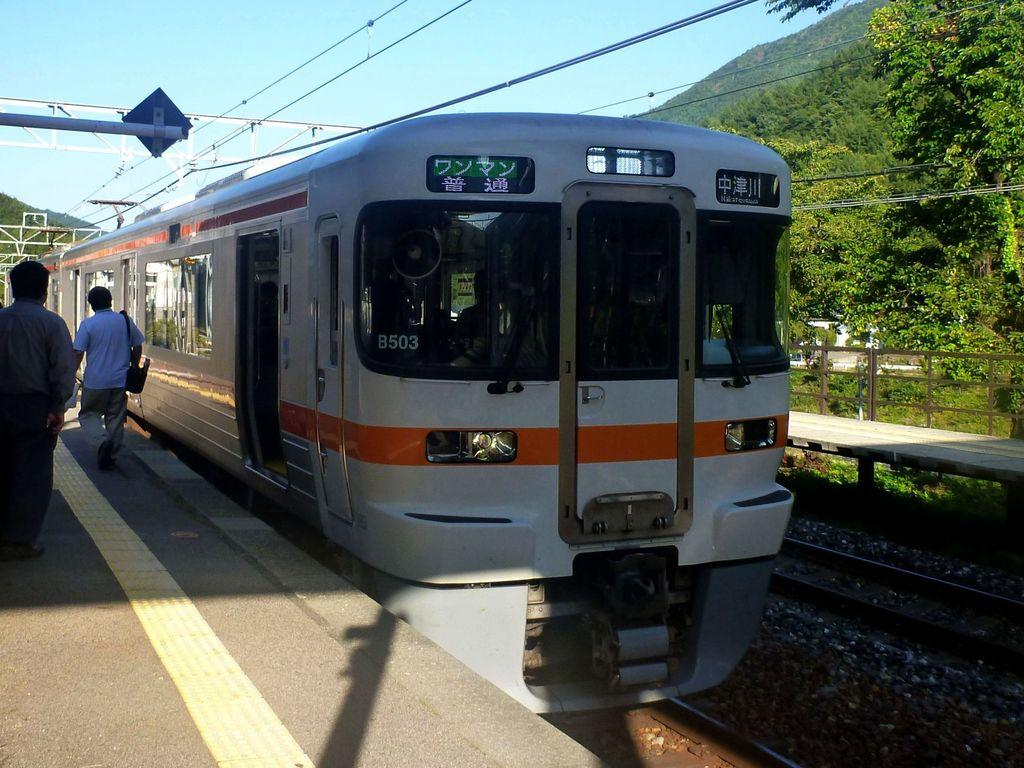What is the main subject of the image? The main subject of the image is a train. What can be seen alongside the train in the image? There are railway tracks in the image. Are there any people visible in the image? Yes, there are two persons on a platform in the image. What type of natural elements can be seen in the image? There are trees, hills, and pebbles in the image. What infrastructure elements can be seen in the image? There are cables and iron strings in the image. What is visible in the background of the image? The sky is visible in the background of the image. What type of impulse is being administered to the train in the image? There is no impulse being administered to the train in the image; it is stationary on the railway tracks. What treatment is being provided to the trees in the image? There is no treatment being provided to the trees in the image; they are simply part of the natural landscape. 